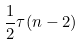<formula> <loc_0><loc_0><loc_500><loc_500>\frac { 1 } { 2 } \tau ( n - 2 )</formula> 